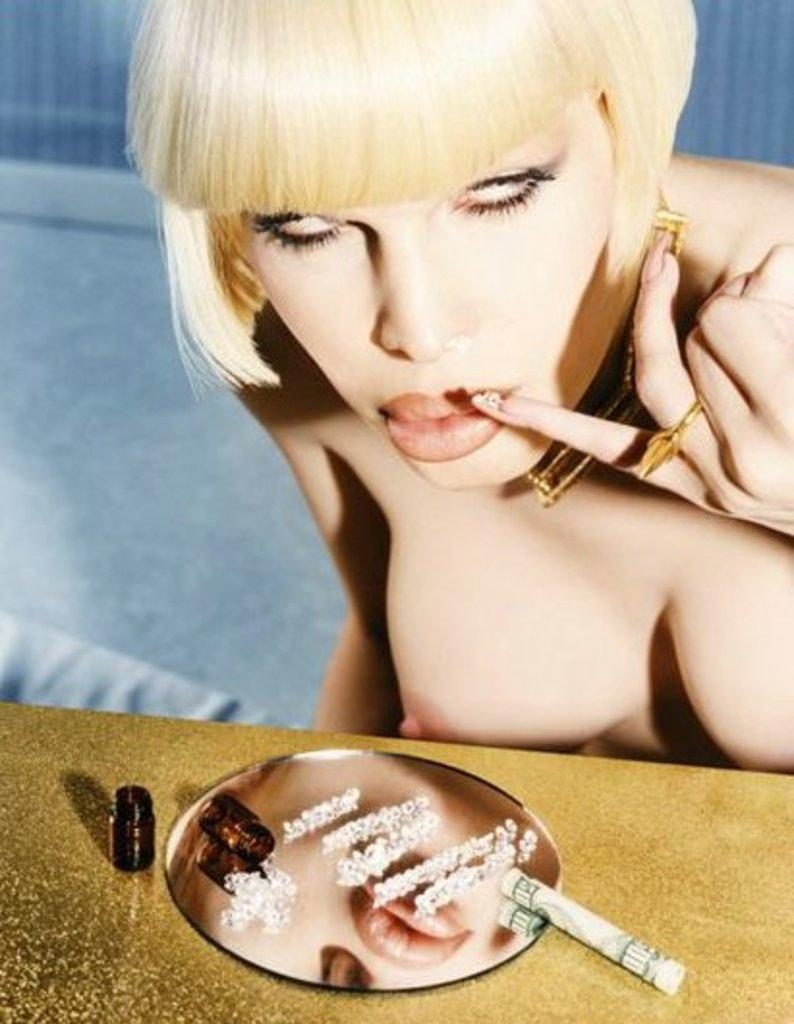Who is the main subject in the image? There is a woman in the image. What is in front of the woman? There is a table in front of the woman. What can be seen on the table? There is a mirror on the table, as well as other objects. How many bushes are visible in the image? There are no bushes visible in the image. What type of ring is the woman wearing in the image? There is no ring visible on the woman in the image. 